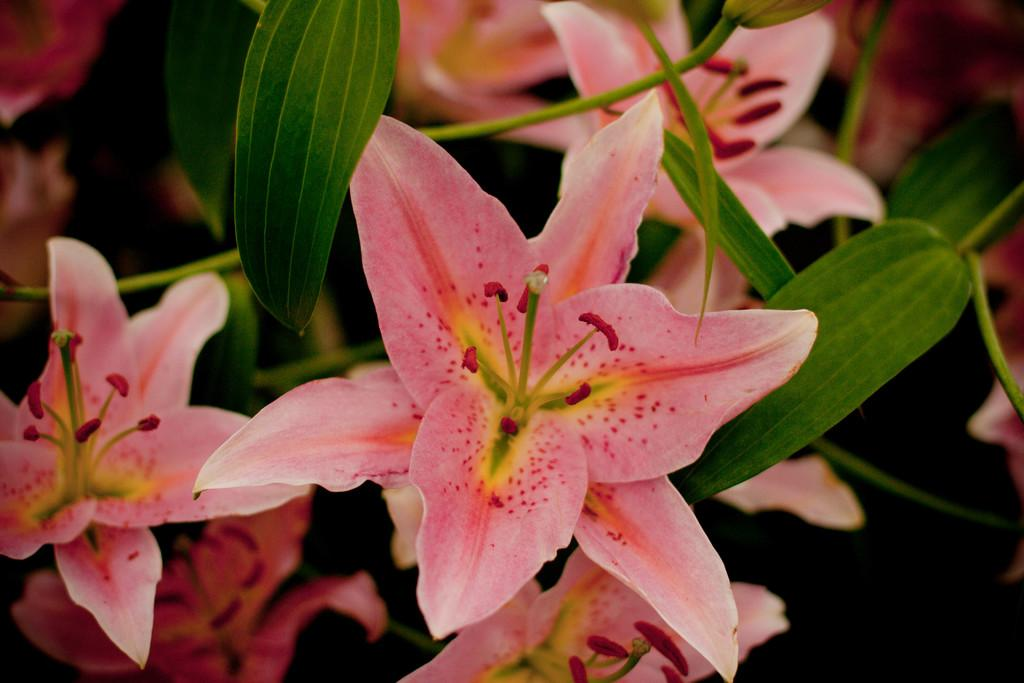What type of plants can be seen in the image? There are flowers and leaves in the image. Can you describe the appearance of the flowers? Unfortunately, the facts provided do not give enough detail to describe the appearance of the flowers. Are the leaves attached to any specific type of plant? Again, the facts provided do not give enough detail to identify the type of plant the leaves are attached to. What recommendations does the committee have for the flowers in the image? There is no committee present in the image, and therefore no recommendations can be given. 